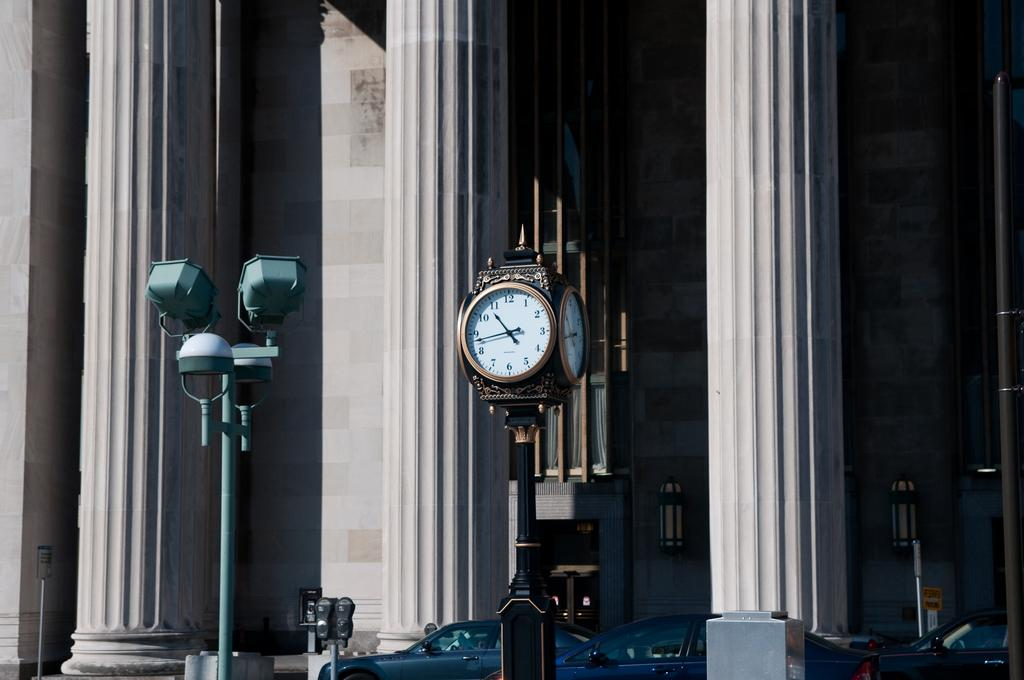<image>
Write a terse but informative summary of the picture. A big clock reads the time at "10:43." 